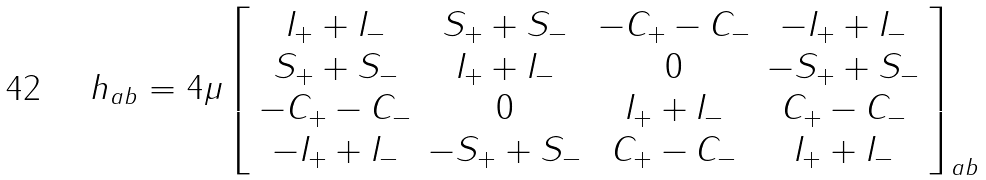<formula> <loc_0><loc_0><loc_500><loc_500>h _ { a b } = 4 \mu \left [ \begin{array} { c c c c } I _ { + } + I _ { - } & S _ { + } + S _ { - } & - C _ { + } - C _ { - } & - I _ { + } + I _ { - } \\ S _ { + } + S _ { - } & I _ { + } + I _ { - } & 0 & - S _ { + } + S _ { - } \\ - C _ { + } - C _ { - } & 0 & I _ { + } + I _ { - } & C _ { + } - C _ { - } \\ - I _ { + } + I _ { - } & - S _ { + } + S _ { - } & C _ { + } - C _ { - } & I _ { + } + I _ { - } \end{array} \right ] _ { a b }</formula> 